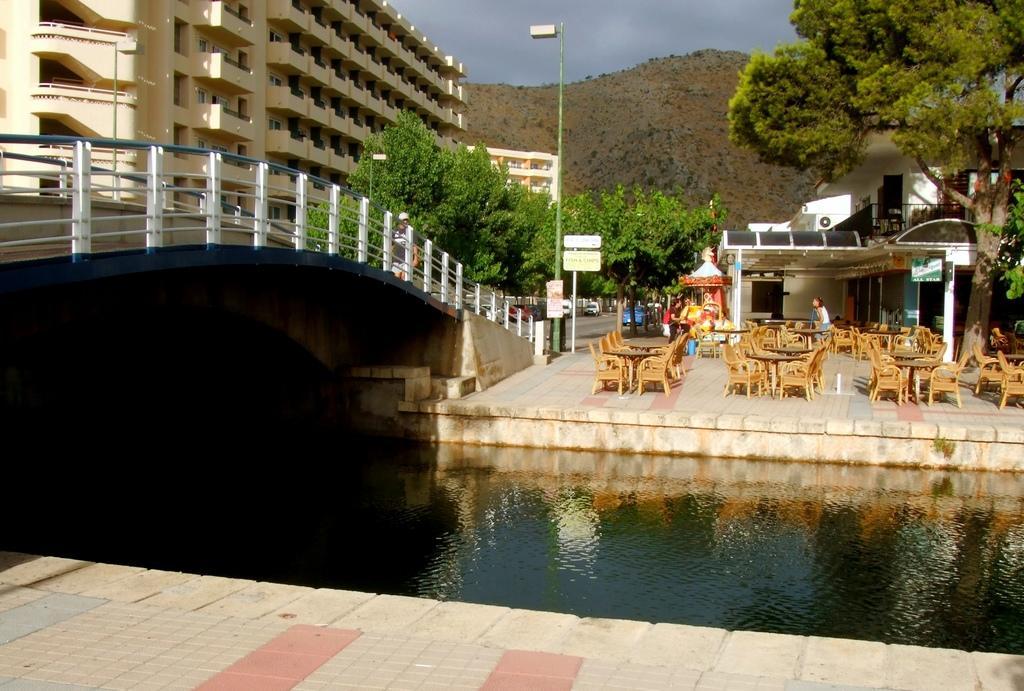Could you give a brief overview of what you see in this image? In this image there is a floor on which there are so many tables and there are so many chairs around them. In the middle there is water. Above the water there is a bridge. At the bottom there is floor. On the right side top corner there is a building. In the background there are hills. At the top there is the sky. On the right side there is a tree. Beside the tree there is a building. 